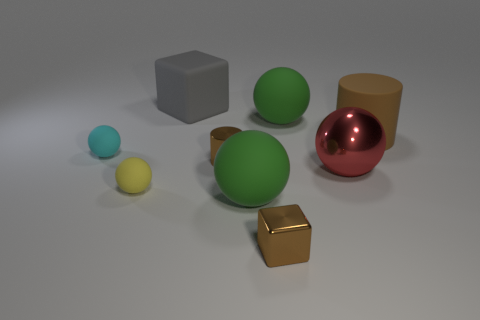Add 1 gray objects. How many objects exist? 10 Subtract all large rubber spheres. How many spheres are left? 3 Subtract all green spheres. How many spheres are left? 3 Subtract all spheres. How many objects are left? 4 Subtract all gray cubes. Subtract all yellow cylinders. How many cubes are left? 1 Subtract all cyan cylinders. How many purple balls are left? 0 Add 2 cyan matte objects. How many cyan matte objects are left? 3 Add 9 large red shiny things. How many large red shiny things exist? 10 Subtract 0 yellow cylinders. How many objects are left? 9 Subtract 1 cylinders. How many cylinders are left? 1 